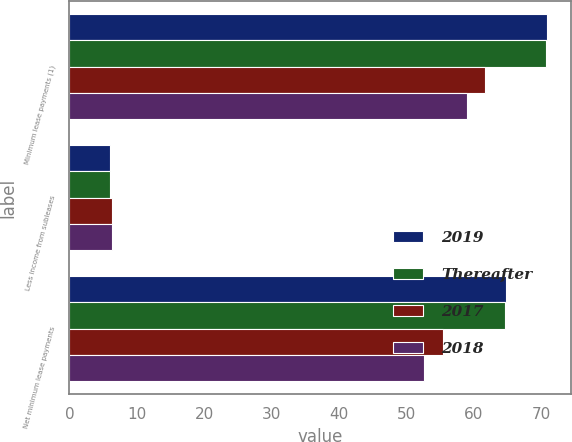Convert chart. <chart><loc_0><loc_0><loc_500><loc_500><stacked_bar_chart><ecel><fcel>Minimum lease payments (1)<fcel>Less income from subleases<fcel>Net minimum lease payments<nl><fcel>2019<fcel>70.8<fcel>6<fcel>64.8<nl><fcel>Thereafter<fcel>70.6<fcel>6<fcel>64.6<nl><fcel>2017<fcel>61.7<fcel>6.3<fcel>55.4<nl><fcel>2018<fcel>58.9<fcel>6.3<fcel>52.6<nl></chart> 